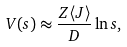<formula> <loc_0><loc_0><loc_500><loc_500>V ( s ) \approx \frac { Z \langle J \rangle } { D } \ln s ,</formula> 